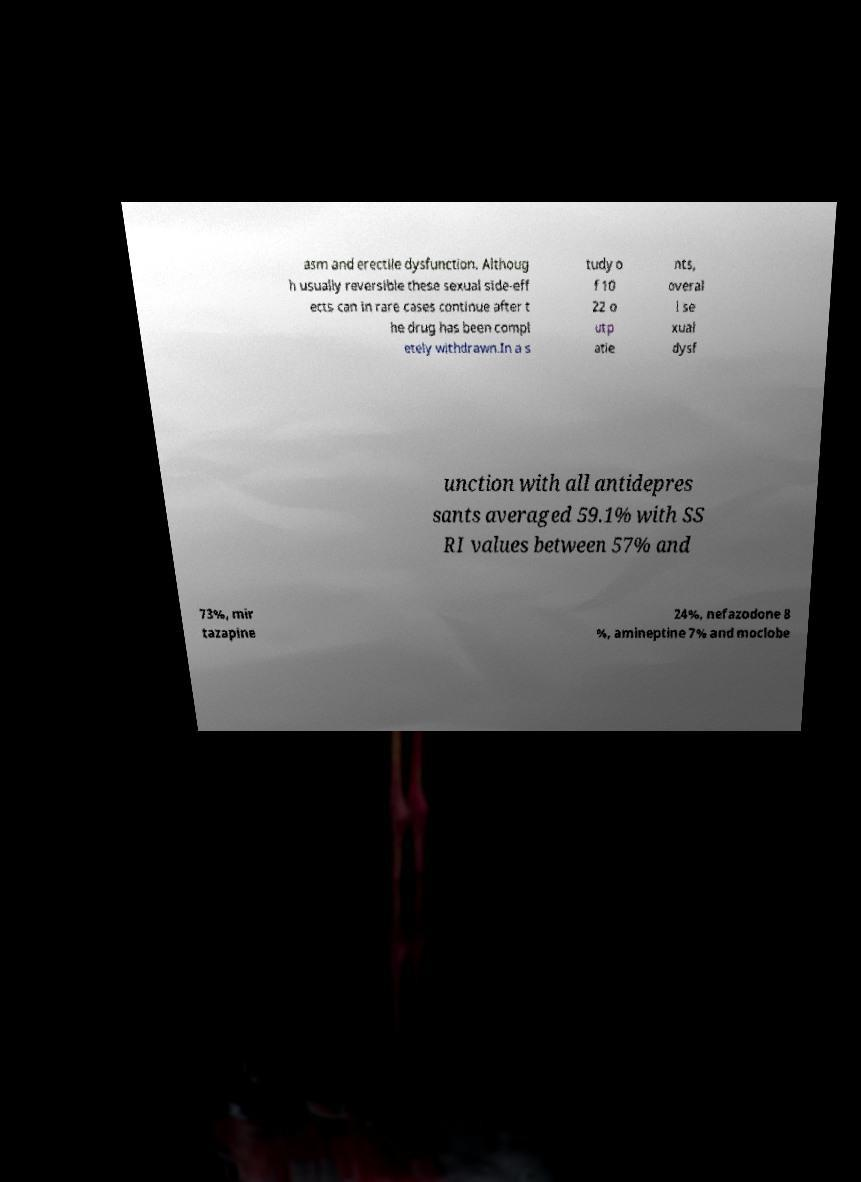Can you read and provide the text displayed in the image?This photo seems to have some interesting text. Can you extract and type it out for me? asm and erectile dysfunction. Althoug h usually reversible these sexual side-eff ects can in rare cases continue after t he drug has been compl etely withdrawn.In a s tudy o f 10 22 o utp atie nts, overal l se xual dysf unction with all antidepres sants averaged 59.1% with SS RI values between 57% and 73%, mir tazapine 24%, nefazodone 8 %, amineptine 7% and moclobe 